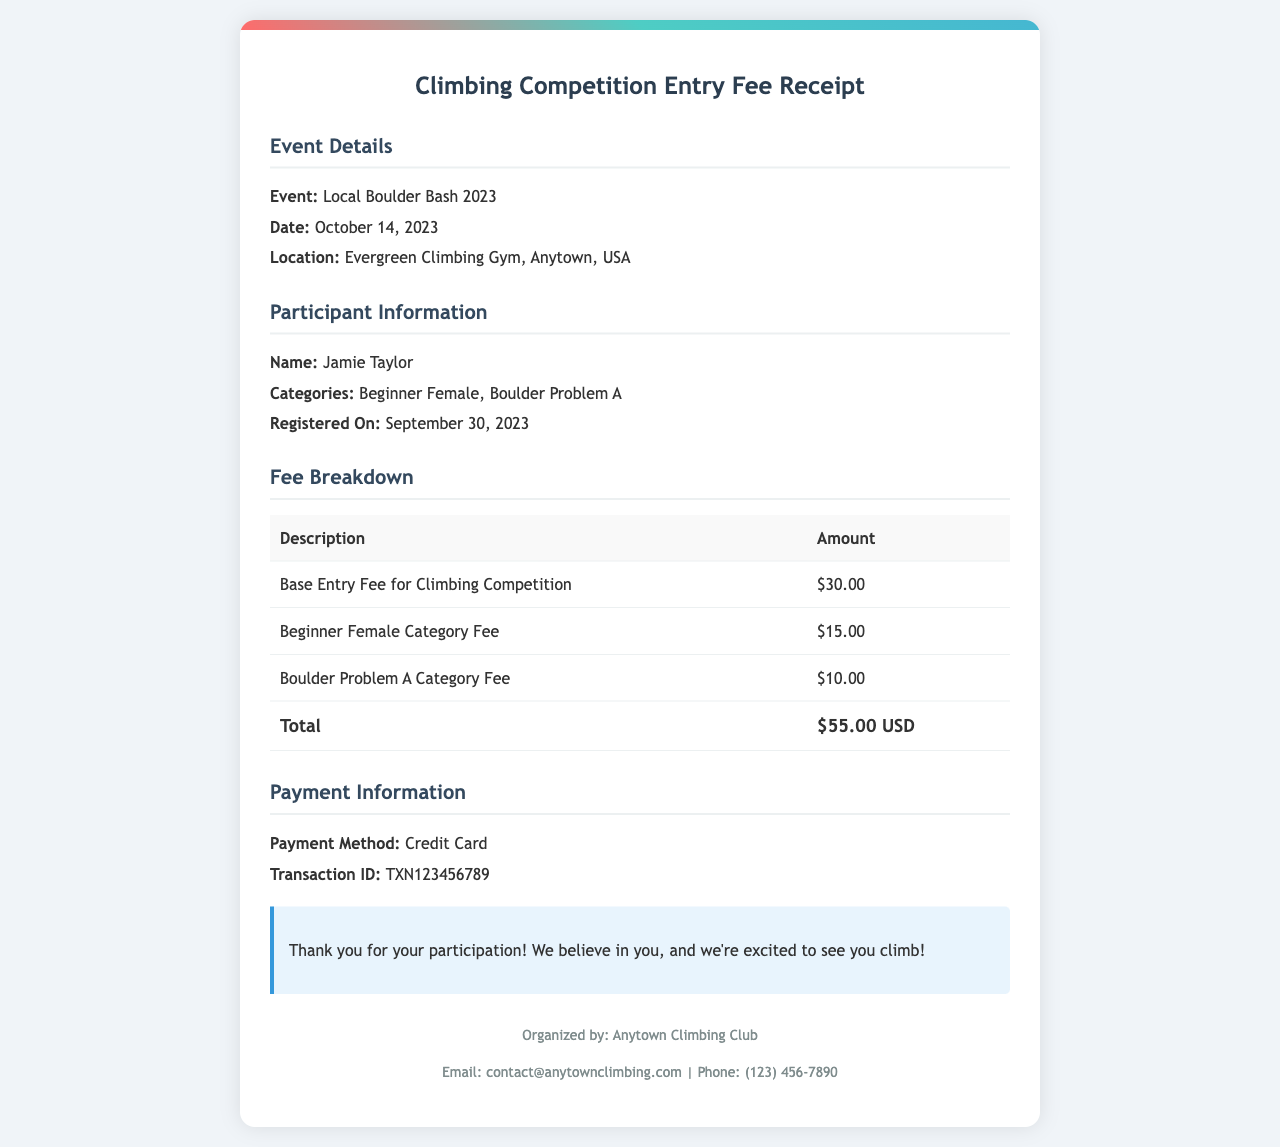what is the event name? The event name is mentioned in the document's event details section.
Answer: Local Boulder Bash 2023 what is the total fee paid? The total fee paid is the final amount listed in the fee breakdown table.
Answer: $55.00 USD who is the participant? The participant's name is provided in the participant information section.
Answer: Jamie Taylor what is the date of the event? The date of the event is outlined in the event details section.
Answer: October 14, 2023 what types of categories did the participant enter? The participant's categories are listed in the participant information section.
Answer: Beginner Female, Boulder Problem A how was the payment made? The payment method is mentioned in the payment information section.
Answer: Credit Card what is the transaction ID? The transaction ID is specified in the payment information section.
Answer: TXN123456789 who organized the event? The organizer's information is included in the footer of the document.
Answer: Anytown Climbing Club what is the base entry fee? The base entry fee is found in the fee breakdown table under description.
Answer: $30.00 